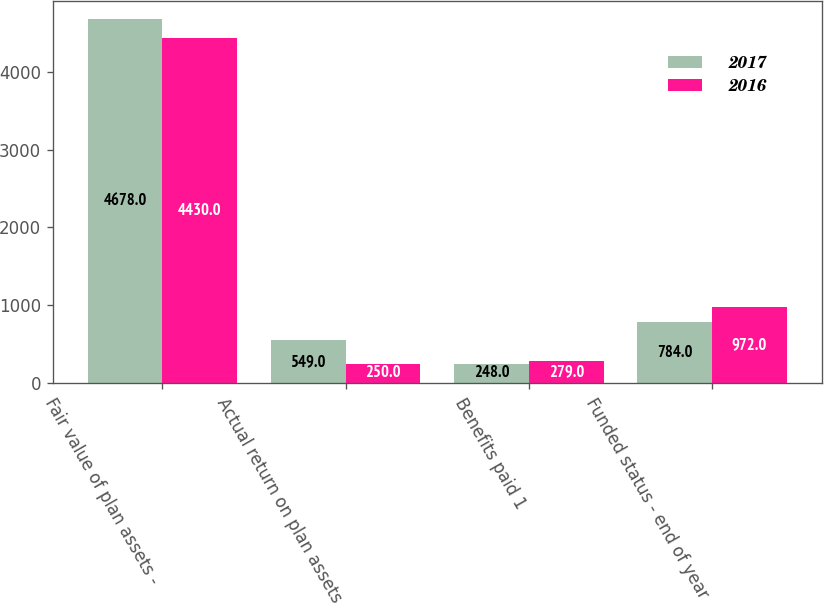Convert chart. <chart><loc_0><loc_0><loc_500><loc_500><stacked_bar_chart><ecel><fcel>Fair value of plan assets -<fcel>Actual return on plan assets<fcel>Benefits paid 1<fcel>Funded status - end of year<nl><fcel>2017<fcel>4678<fcel>549<fcel>248<fcel>784<nl><fcel>2016<fcel>4430<fcel>250<fcel>279<fcel>972<nl></chart> 